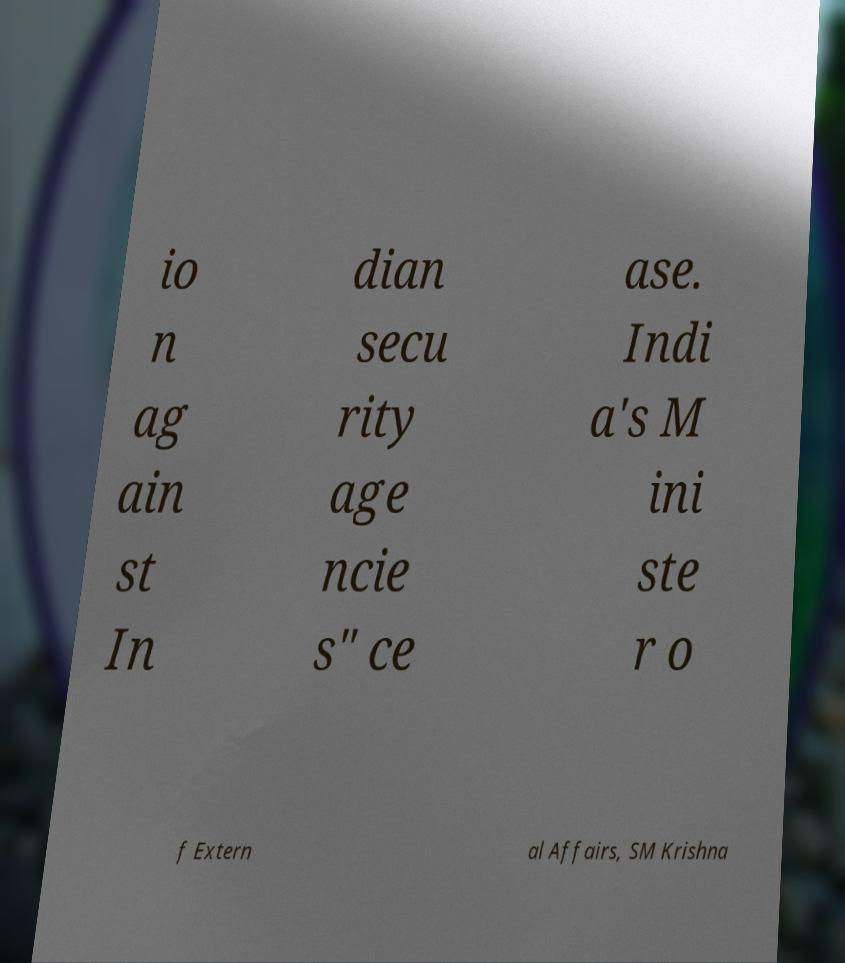For documentation purposes, I need the text within this image transcribed. Could you provide that? io n ag ain st In dian secu rity age ncie s" ce ase. Indi a's M ini ste r o f Extern al Affairs, SM Krishna 